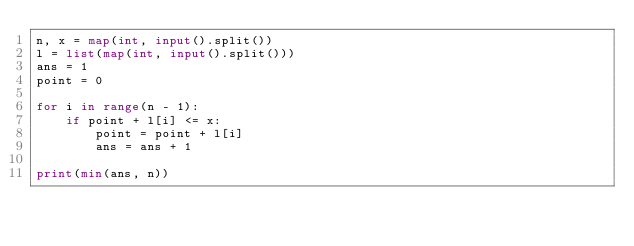Convert code to text. <code><loc_0><loc_0><loc_500><loc_500><_Python_>n, x = map(int, input().split())
l = list(map(int, input().split()))
ans = 1
point = 0

for i in range(n - 1):
    if point + l[i] <= x:
        point = point + l[i]
        ans = ans + 1

print(min(ans, n))</code> 